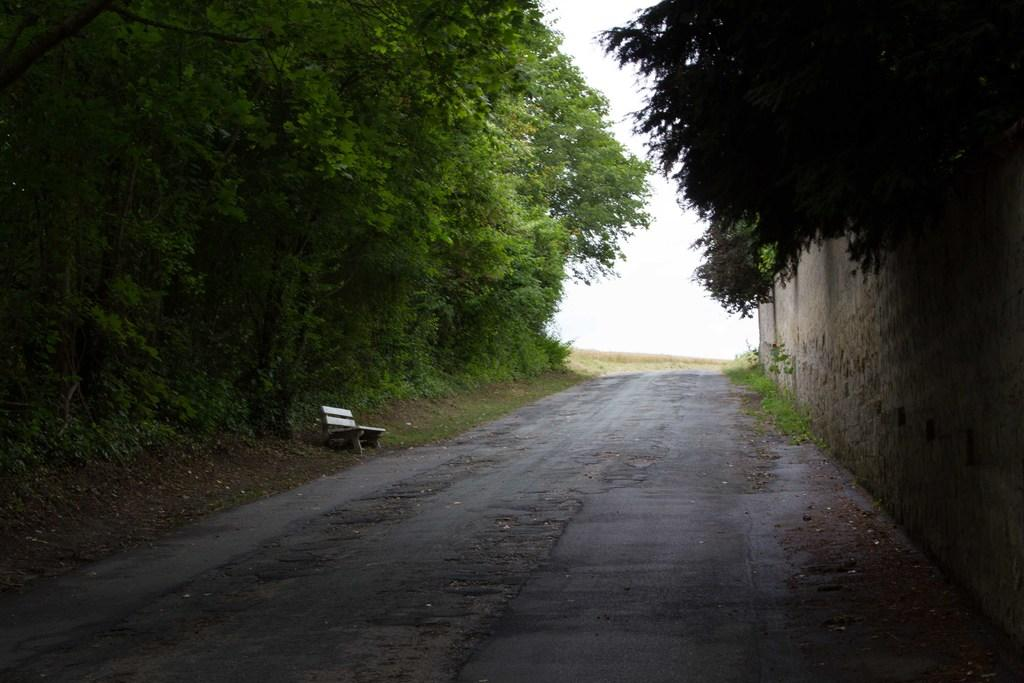What is located in the foreground of the image? There is a path and a bench in the foreground of the image. What type of vegetation can be seen in the background of the image? There is greenery visible in the background of the image. What is visible in the sky in the background of the image? The sky is visible in the background of the image. What is on the right side of the image? There is a wall on the right side of the image. Is the bench hot to the touch in the image? The image does not provide information about the temperature of the bench, so we cannot determine if it is hot or not. What type of school can be seen in the image? There is no school present in the image. 